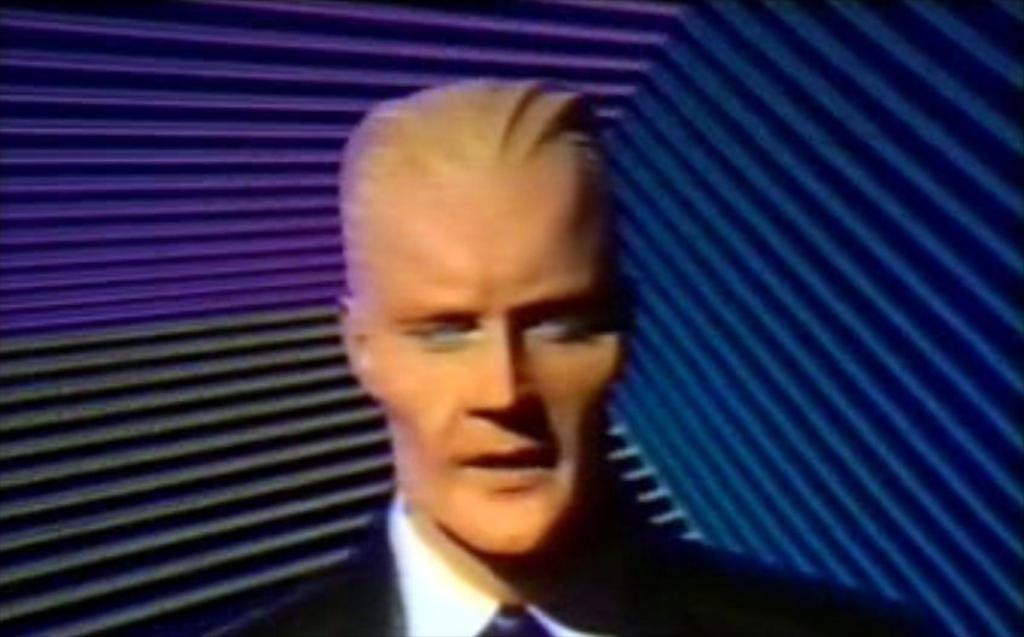What type of image is being described? The image is animated. Can you describe the subject of the image? There is a person in the image. What does the person in the image attempt to do with their grandmother? There is no mention of a grandmother or any attempt to do something in the image. 